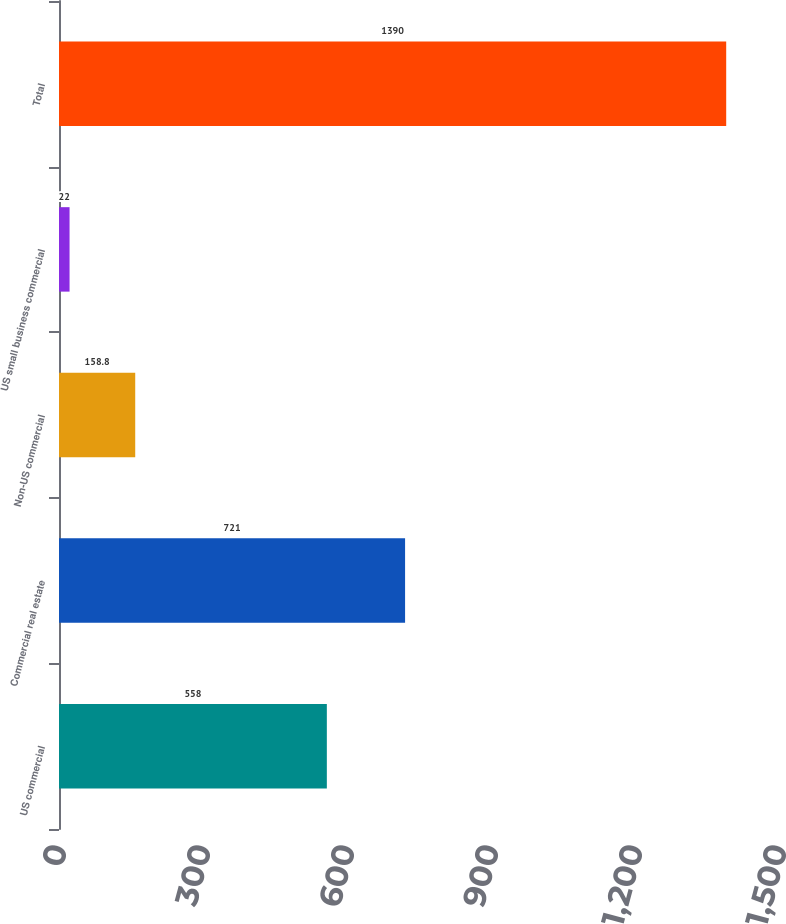Convert chart. <chart><loc_0><loc_0><loc_500><loc_500><bar_chart><fcel>US commercial<fcel>Commercial real estate<fcel>Non-US commercial<fcel>US small business commercial<fcel>Total<nl><fcel>558<fcel>721<fcel>158.8<fcel>22<fcel>1390<nl></chart> 